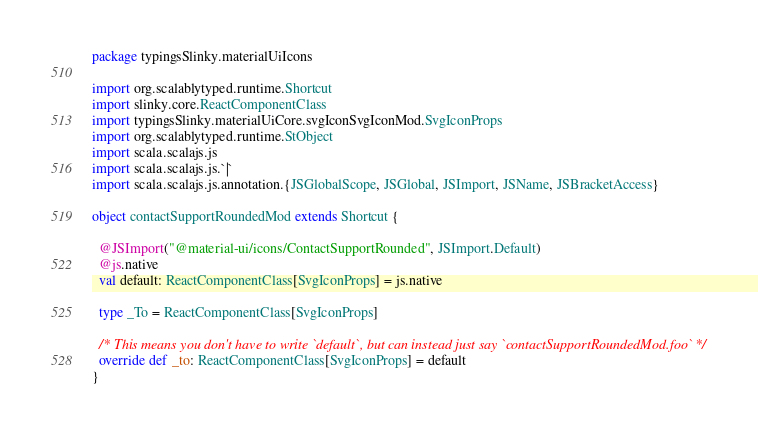Convert code to text. <code><loc_0><loc_0><loc_500><loc_500><_Scala_>package typingsSlinky.materialUiIcons

import org.scalablytyped.runtime.Shortcut
import slinky.core.ReactComponentClass
import typingsSlinky.materialUiCore.svgIconSvgIconMod.SvgIconProps
import org.scalablytyped.runtime.StObject
import scala.scalajs.js
import scala.scalajs.js.`|`
import scala.scalajs.js.annotation.{JSGlobalScope, JSGlobal, JSImport, JSName, JSBracketAccess}

object contactSupportRoundedMod extends Shortcut {
  
  @JSImport("@material-ui/icons/ContactSupportRounded", JSImport.Default)
  @js.native
  val default: ReactComponentClass[SvgIconProps] = js.native
  
  type _To = ReactComponentClass[SvgIconProps]
  
  /* This means you don't have to write `default`, but can instead just say `contactSupportRoundedMod.foo` */
  override def _to: ReactComponentClass[SvgIconProps] = default
}
</code> 